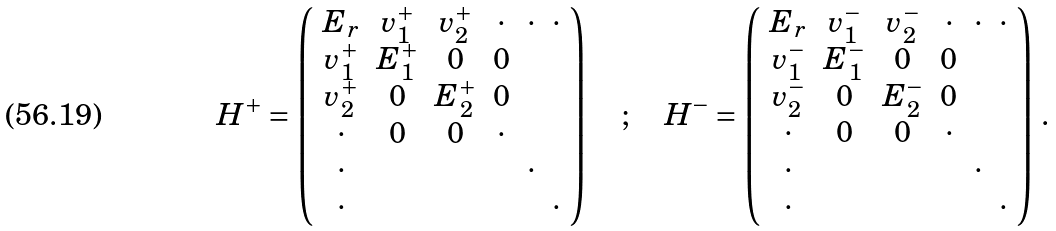<formula> <loc_0><loc_0><loc_500><loc_500>H ^ { + } = \left ( \begin{array} { c c c c c c } E _ { r } & v _ { 1 } ^ { + } & v _ { 2 } ^ { + } & \cdot & \cdot & \cdot \\ v _ { 1 } ^ { + } & E _ { 1 } ^ { + } & 0 & 0 & & \\ v _ { 2 } ^ { + } & 0 & E _ { 2 } ^ { + } & 0 & & \\ \cdot & 0 & 0 & \cdot & & \\ \cdot & & & & \cdot & \\ \cdot & & & & & \cdot \\ \end{array} \right ) \quad ; \quad H ^ { - } = \left ( \begin{array} { c c c c c c } E _ { r } & v _ { 1 } ^ { - } & v _ { 2 } ^ { - } & \cdot & \cdot & \cdot \\ v _ { 1 } ^ { - } & E _ { 1 } ^ { - } & 0 & 0 & & \\ v _ { 2 } ^ { - } & 0 & E _ { 2 } ^ { - } & 0 & & \\ \cdot & 0 & 0 & \cdot & & \\ \cdot & & & & \cdot & \\ \cdot & & & & & \cdot \\ \end{array} \right ) \, .</formula> 